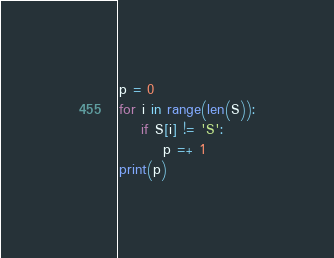Convert code to text. <code><loc_0><loc_0><loc_500><loc_500><_Python_>p = 0
for i in range(len(S)):
    if S[i] != 'S':
        p =+ 1
print(p)
</code> 